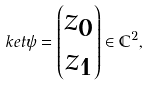<formula> <loc_0><loc_0><loc_500><loc_500>\ k e t { \psi } = \begin{pmatrix} z _ { 0 } \\ z _ { 1 } \end{pmatrix} \in \mathbb { C } ^ { 2 } ,</formula> 